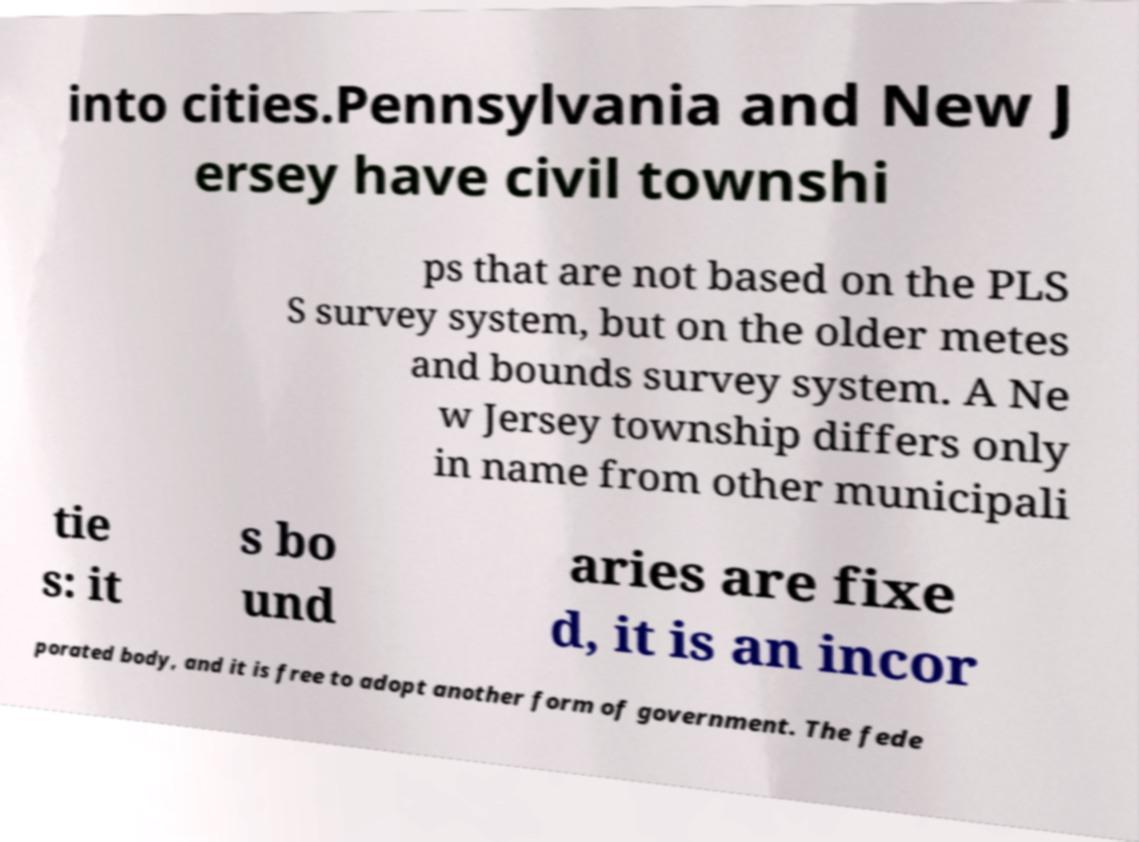Could you extract and type out the text from this image? into cities.Pennsylvania and New J ersey have civil townshi ps that are not based on the PLS S survey system, but on the older metes and bounds survey system. A Ne w Jersey township differs only in name from other municipali tie s: it s bo und aries are fixe d, it is an incor porated body, and it is free to adopt another form of government. The fede 